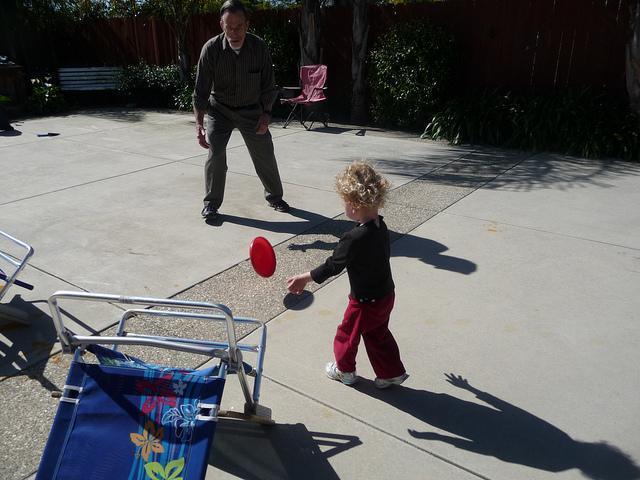How many people are visible?
Give a very brief answer. 2. 